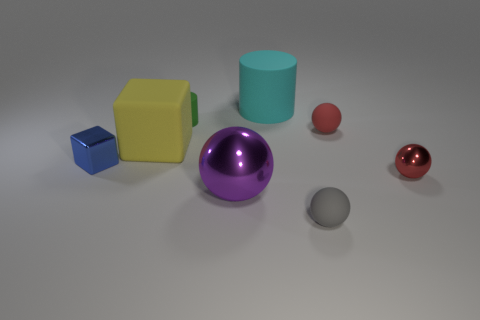Do any of these objects share a similar color tone? Yes, the teal cylinder and the small blue cube share a similar color tone, both having elements of blue in their coloration, albeit different shades.  Can you tell me about the lighting and shadows in the scene? The lighting in the scene is coming from above, casting soft shadows directly below the objects, indicating a single diffuse light source, likely meant to simulate an indoor environment without harsh lighting. 